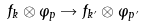Convert formula to latex. <formula><loc_0><loc_0><loc_500><loc_500>f _ { k } \otimes \varphi _ { p } \rightarrow f _ { k ^ { \prime } } \otimes \varphi _ { p \, ^ { \prime } }</formula> 